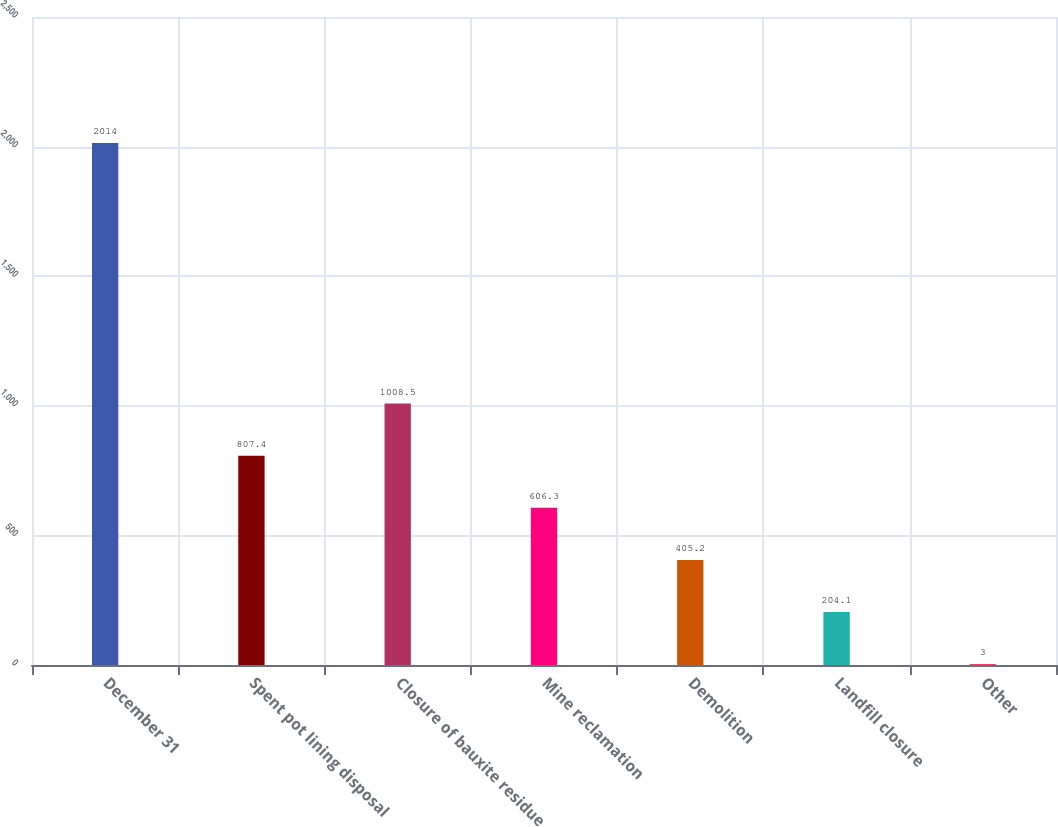Convert chart. <chart><loc_0><loc_0><loc_500><loc_500><bar_chart><fcel>December 31<fcel>Spent pot lining disposal<fcel>Closure of bauxite residue<fcel>Mine reclamation<fcel>Demolition<fcel>Landfill closure<fcel>Other<nl><fcel>2014<fcel>807.4<fcel>1008.5<fcel>606.3<fcel>405.2<fcel>204.1<fcel>3<nl></chart> 